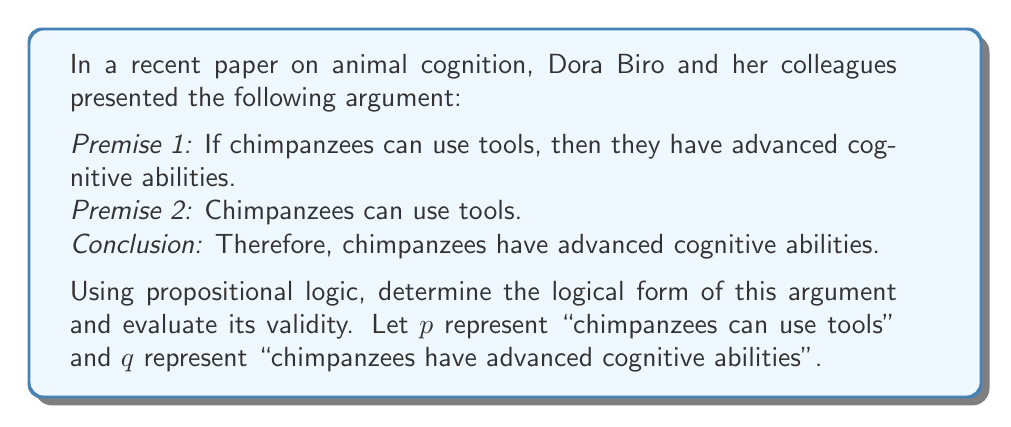Can you answer this question? To evaluate the validity of this argument using formal logic, we'll follow these steps:

1. Identify the logical form of the argument:
   Premise 1: $p \implies q$ (If p, then q)
   Premise 2: $p$
   Conclusion: $q$

2. Recognize the argument structure:
   This argument follows the logical form known as Modus Ponens, which is represented as:

   $$ \frac{p \implies q, \quad p}{q} $$

3. Evaluate the validity:
   Modus Ponens is a valid argument form in propositional logic. To prove this, we can use a truth table:

   $$
   \begin{array}{|c|c|c|c|}
   \hline
   p & q & p \implies q & (p \implies q) \land p \implies q \\
   \hline
   T & T & T & T \\
   T & F & F & T \\
   F & T & T & T \\
   F & F & T & T \\
   \hline
   \end{array}
   $$

   The last column shows that the argument is valid for all possible truth value assignments to p and q.

4. Interpret the results:
   Since the argument follows the valid form of Modus Ponens, we can conclude that it is a valid argument. This means that if the premises are true, the conclusion must also be true.

5. Consider the context:
   In the field of animal cognition, this logical analysis supports the validity of Dora Biro and her colleagues' argument structure. However, it's important to note that logical validity doesn't guarantee the truth of the premises or the conclusion in the real world. The strength of the argument in a scientific context would also depend on the empirical evidence supporting the premises.
Answer: The argument is valid, following the Modus Ponens logical form: $\frac{p \implies q, \quad p}{q}$ 